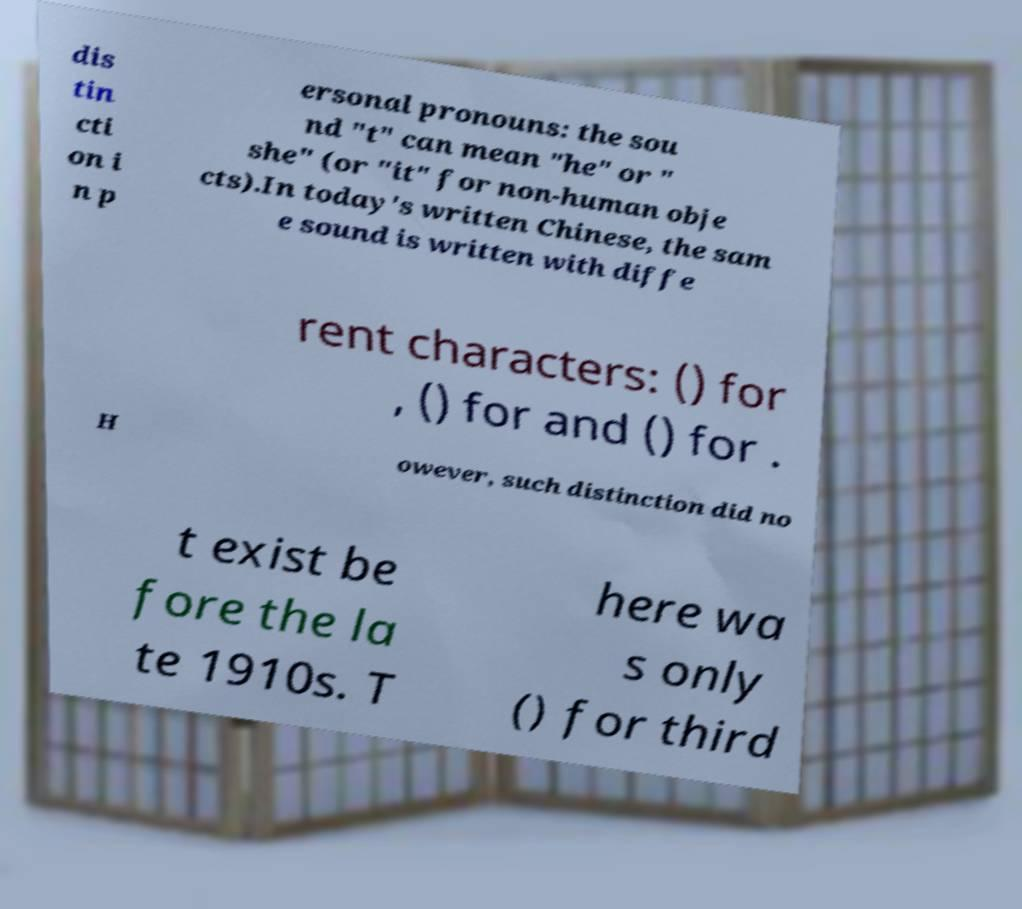There's text embedded in this image that I need extracted. Can you transcribe it verbatim? dis tin cti on i n p ersonal pronouns: the sou nd "t" can mean "he" or " she" (or "it" for non-human obje cts).In today's written Chinese, the sam e sound is written with diffe rent characters: () for , () for and () for . H owever, such distinction did no t exist be fore the la te 1910s. T here wa s only () for third 